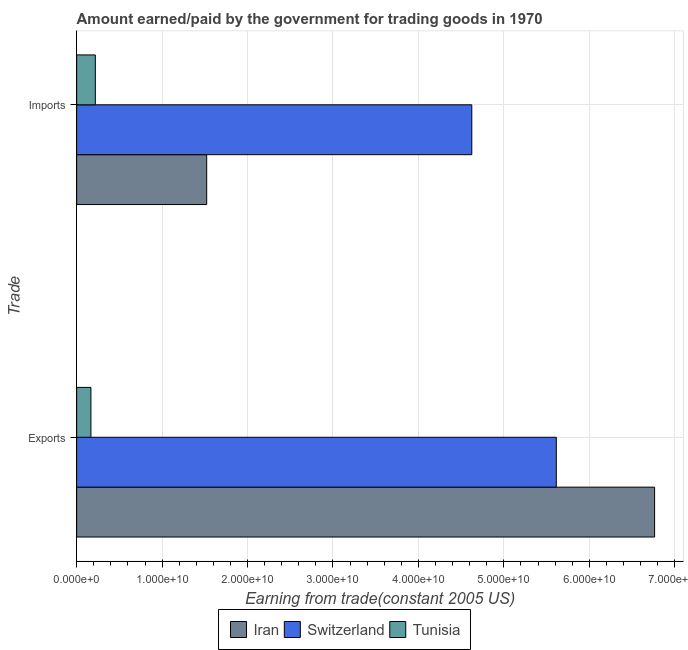How many different coloured bars are there?
Ensure brevity in your answer.  3. How many groups of bars are there?
Your response must be concise. 2. Are the number of bars per tick equal to the number of legend labels?
Make the answer very short. Yes. How many bars are there on the 1st tick from the top?
Keep it short and to the point. 3. What is the label of the 1st group of bars from the top?
Provide a succinct answer. Imports. What is the amount paid for imports in Switzerland?
Your response must be concise. 4.62e+1. Across all countries, what is the maximum amount earned from exports?
Offer a very short reply. 6.76e+1. Across all countries, what is the minimum amount paid for imports?
Keep it short and to the point. 2.19e+09. In which country was the amount paid for imports maximum?
Ensure brevity in your answer.  Switzerland. In which country was the amount earned from exports minimum?
Provide a succinct answer. Tunisia. What is the total amount paid for imports in the graph?
Make the answer very short. 6.37e+1. What is the difference between the amount earned from exports in Switzerland and that in Tunisia?
Offer a very short reply. 5.45e+1. What is the difference between the amount paid for imports in Iran and the amount earned from exports in Tunisia?
Give a very brief answer. 1.36e+1. What is the average amount earned from exports per country?
Offer a terse response. 4.18e+1. What is the difference between the amount paid for imports and amount earned from exports in Tunisia?
Your answer should be very brief. 5.17e+08. What is the ratio of the amount paid for imports in Switzerland to that in Iran?
Provide a short and direct response. 3.04. Is the amount paid for imports in Switzerland less than that in Iran?
Offer a terse response. No. In how many countries, is the amount paid for imports greater than the average amount paid for imports taken over all countries?
Offer a terse response. 1. What does the 3rd bar from the top in Exports represents?
Keep it short and to the point. Iran. What does the 1st bar from the bottom in Exports represents?
Ensure brevity in your answer.  Iran. How many bars are there?
Make the answer very short. 6. Are all the bars in the graph horizontal?
Ensure brevity in your answer.  Yes. How many countries are there in the graph?
Provide a succinct answer. 3. Are the values on the major ticks of X-axis written in scientific E-notation?
Keep it short and to the point. Yes. Does the graph contain grids?
Offer a terse response. Yes. Where does the legend appear in the graph?
Ensure brevity in your answer.  Bottom center. How many legend labels are there?
Keep it short and to the point. 3. How are the legend labels stacked?
Provide a short and direct response. Horizontal. What is the title of the graph?
Offer a terse response. Amount earned/paid by the government for trading goods in 1970. What is the label or title of the X-axis?
Give a very brief answer. Earning from trade(constant 2005 US). What is the label or title of the Y-axis?
Offer a very short reply. Trade. What is the Earning from trade(constant 2005 US) of Iran in Exports?
Provide a short and direct response. 6.76e+1. What is the Earning from trade(constant 2005 US) of Switzerland in Exports?
Your response must be concise. 5.61e+1. What is the Earning from trade(constant 2005 US) in Tunisia in Exports?
Offer a terse response. 1.67e+09. What is the Earning from trade(constant 2005 US) of Iran in Imports?
Your answer should be very brief. 1.52e+1. What is the Earning from trade(constant 2005 US) in Switzerland in Imports?
Your answer should be compact. 4.62e+1. What is the Earning from trade(constant 2005 US) in Tunisia in Imports?
Your answer should be very brief. 2.19e+09. Across all Trade, what is the maximum Earning from trade(constant 2005 US) of Iran?
Your answer should be very brief. 6.76e+1. Across all Trade, what is the maximum Earning from trade(constant 2005 US) of Switzerland?
Make the answer very short. 5.61e+1. Across all Trade, what is the maximum Earning from trade(constant 2005 US) of Tunisia?
Make the answer very short. 2.19e+09. Across all Trade, what is the minimum Earning from trade(constant 2005 US) in Iran?
Your answer should be very brief. 1.52e+1. Across all Trade, what is the minimum Earning from trade(constant 2005 US) of Switzerland?
Keep it short and to the point. 4.62e+1. Across all Trade, what is the minimum Earning from trade(constant 2005 US) of Tunisia?
Provide a succinct answer. 1.67e+09. What is the total Earning from trade(constant 2005 US) of Iran in the graph?
Offer a very short reply. 8.29e+1. What is the total Earning from trade(constant 2005 US) of Switzerland in the graph?
Keep it short and to the point. 1.02e+11. What is the total Earning from trade(constant 2005 US) in Tunisia in the graph?
Offer a very short reply. 3.85e+09. What is the difference between the Earning from trade(constant 2005 US) in Iran in Exports and that in Imports?
Your response must be concise. 5.24e+1. What is the difference between the Earning from trade(constant 2005 US) of Switzerland in Exports and that in Imports?
Make the answer very short. 9.89e+09. What is the difference between the Earning from trade(constant 2005 US) in Tunisia in Exports and that in Imports?
Your answer should be very brief. -5.17e+08. What is the difference between the Earning from trade(constant 2005 US) of Iran in Exports and the Earning from trade(constant 2005 US) of Switzerland in Imports?
Give a very brief answer. 2.14e+1. What is the difference between the Earning from trade(constant 2005 US) in Iran in Exports and the Earning from trade(constant 2005 US) in Tunisia in Imports?
Provide a succinct answer. 6.55e+1. What is the difference between the Earning from trade(constant 2005 US) of Switzerland in Exports and the Earning from trade(constant 2005 US) of Tunisia in Imports?
Your response must be concise. 5.40e+1. What is the average Earning from trade(constant 2005 US) of Iran per Trade?
Provide a short and direct response. 4.14e+1. What is the average Earning from trade(constant 2005 US) in Switzerland per Trade?
Give a very brief answer. 5.12e+1. What is the average Earning from trade(constant 2005 US) of Tunisia per Trade?
Your answer should be very brief. 1.93e+09. What is the difference between the Earning from trade(constant 2005 US) in Iran and Earning from trade(constant 2005 US) in Switzerland in Exports?
Make the answer very short. 1.15e+1. What is the difference between the Earning from trade(constant 2005 US) of Iran and Earning from trade(constant 2005 US) of Tunisia in Exports?
Give a very brief answer. 6.60e+1. What is the difference between the Earning from trade(constant 2005 US) of Switzerland and Earning from trade(constant 2005 US) of Tunisia in Exports?
Your answer should be compact. 5.45e+1. What is the difference between the Earning from trade(constant 2005 US) in Iran and Earning from trade(constant 2005 US) in Switzerland in Imports?
Ensure brevity in your answer.  -3.10e+1. What is the difference between the Earning from trade(constant 2005 US) of Iran and Earning from trade(constant 2005 US) of Tunisia in Imports?
Your answer should be very brief. 1.30e+1. What is the difference between the Earning from trade(constant 2005 US) in Switzerland and Earning from trade(constant 2005 US) in Tunisia in Imports?
Your answer should be very brief. 4.41e+1. What is the ratio of the Earning from trade(constant 2005 US) in Iran in Exports to that in Imports?
Offer a very short reply. 4.44. What is the ratio of the Earning from trade(constant 2005 US) of Switzerland in Exports to that in Imports?
Your answer should be compact. 1.21. What is the ratio of the Earning from trade(constant 2005 US) in Tunisia in Exports to that in Imports?
Your answer should be very brief. 0.76. What is the difference between the highest and the second highest Earning from trade(constant 2005 US) of Iran?
Provide a short and direct response. 5.24e+1. What is the difference between the highest and the second highest Earning from trade(constant 2005 US) of Switzerland?
Your answer should be very brief. 9.89e+09. What is the difference between the highest and the second highest Earning from trade(constant 2005 US) in Tunisia?
Offer a very short reply. 5.17e+08. What is the difference between the highest and the lowest Earning from trade(constant 2005 US) in Iran?
Give a very brief answer. 5.24e+1. What is the difference between the highest and the lowest Earning from trade(constant 2005 US) of Switzerland?
Your answer should be very brief. 9.89e+09. What is the difference between the highest and the lowest Earning from trade(constant 2005 US) in Tunisia?
Make the answer very short. 5.17e+08. 